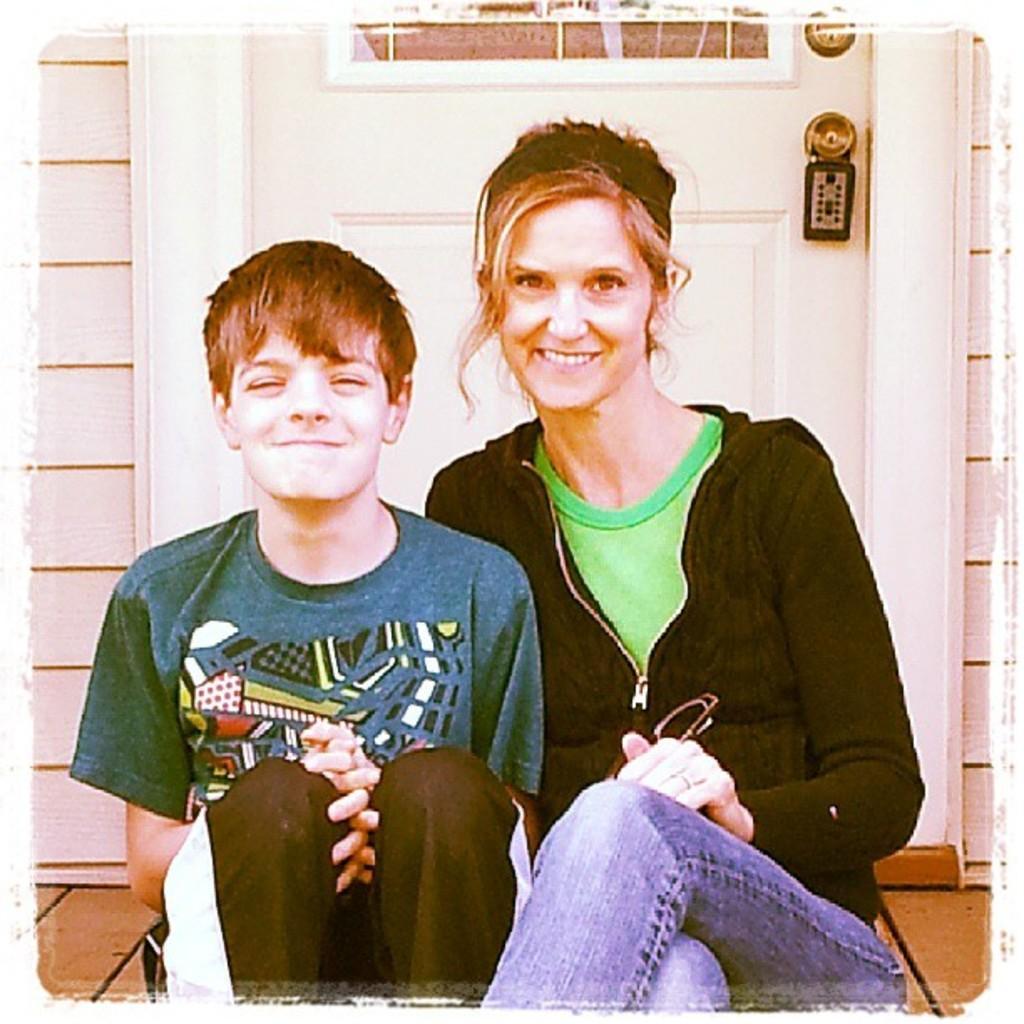Describe this image in one or two sentences. Here I can see a woman and a boy are sitting on the floor, smiling and giving pose for the picture. The woman is wearing a black color jacket, jeans and holding spectacles in the hand. The boy is wearing a t-shirt and trouser. At the back of these people I can see a white color door along with the wall. 